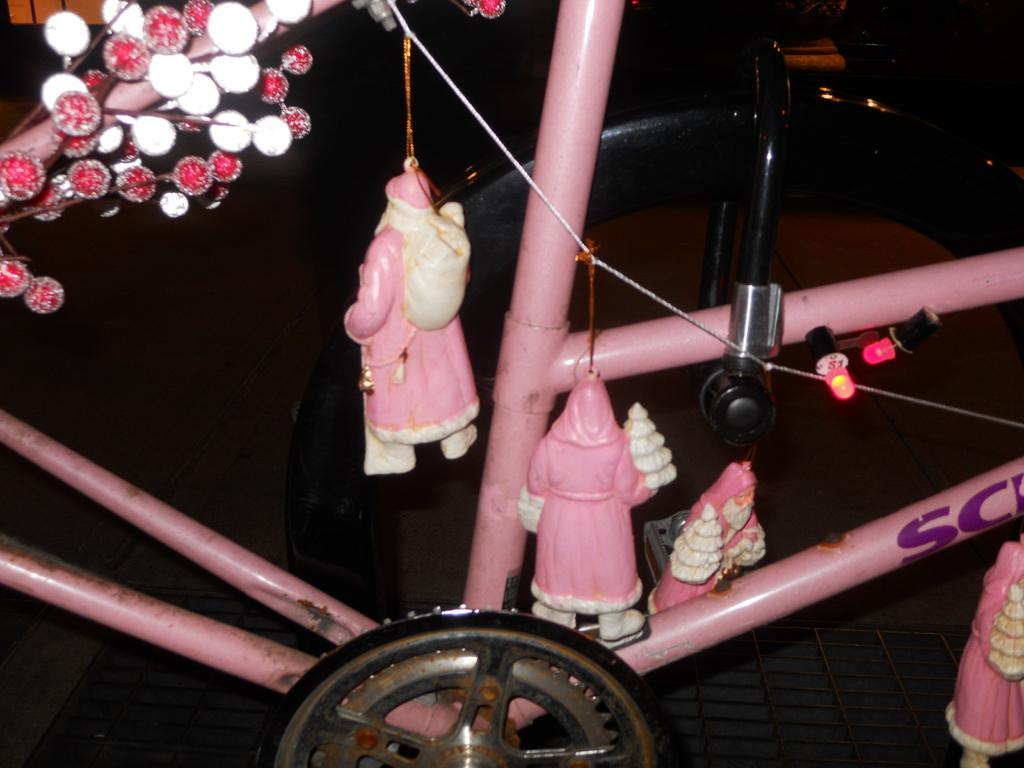Describe this image in one or two sentences. This image looks like a cycle. It has toys of Santa Claus. 